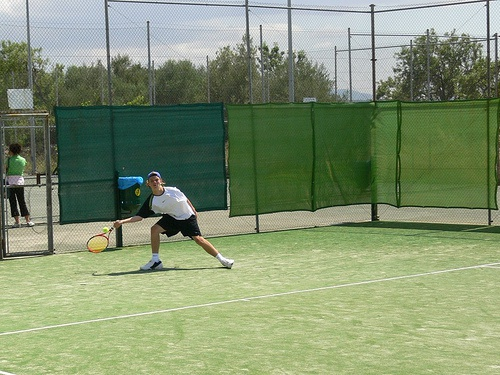Describe the objects in this image and their specific colors. I can see people in white, black, darkgray, and gray tones, people in white, black, darkgray, gray, and darkgreen tones, tennis racket in white, tan, and khaki tones, handbag in white, black, and gray tones, and sports ball in white, khaki, lightgreen, and olive tones in this image. 